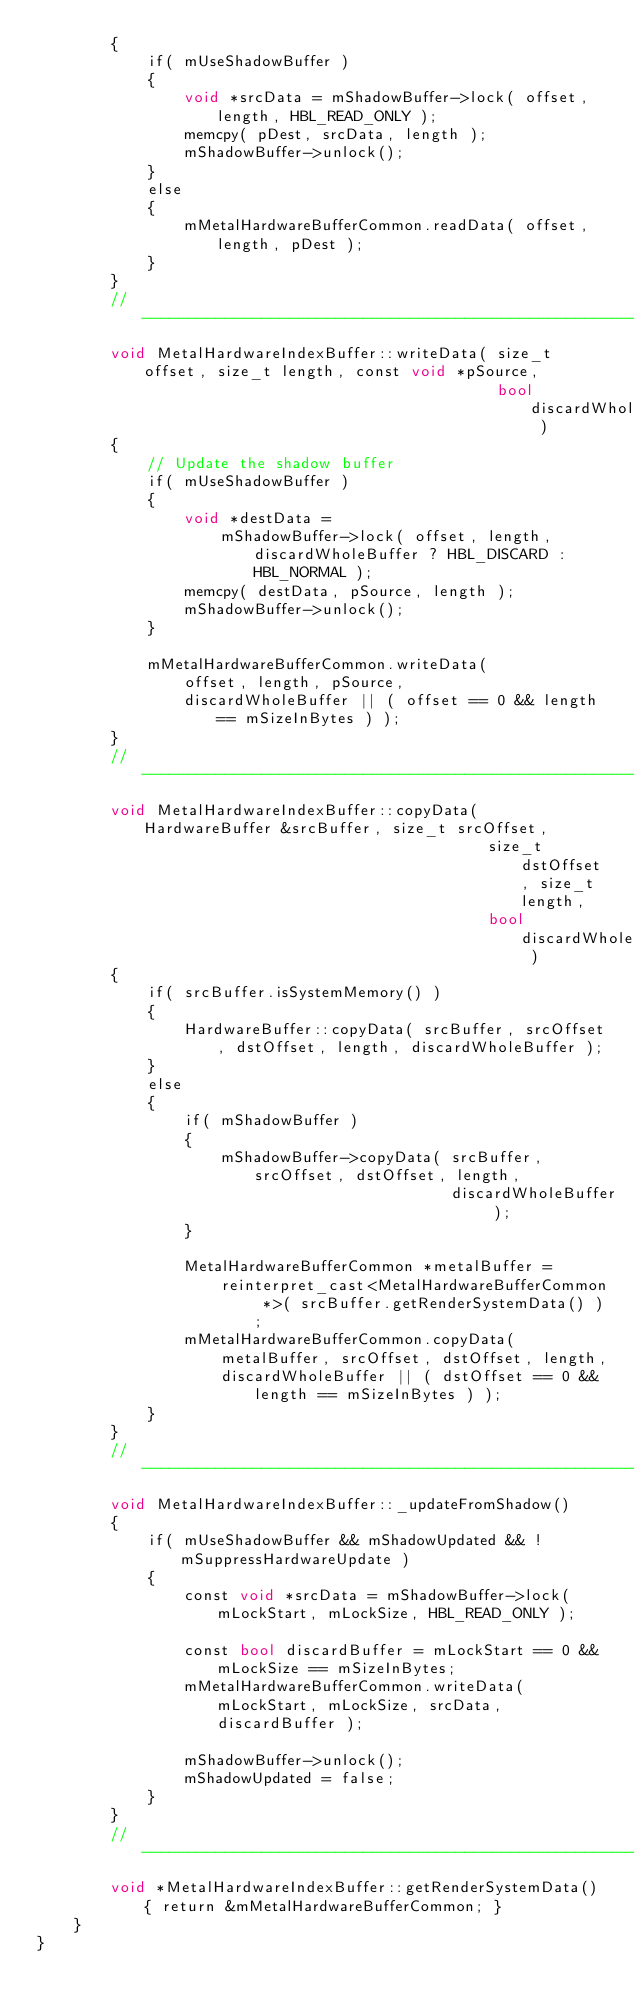Convert code to text. <code><loc_0><loc_0><loc_500><loc_500><_ObjectiveC_>        {
            if( mUseShadowBuffer )
            {
                void *srcData = mShadowBuffer->lock( offset, length, HBL_READ_ONLY );
                memcpy( pDest, srcData, length );
                mShadowBuffer->unlock();
            }
            else
            {
                mMetalHardwareBufferCommon.readData( offset, length, pDest );
            }
        }
        //-----------------------------------------------------------------------------------
        void MetalHardwareIndexBuffer::writeData( size_t offset, size_t length, const void *pSource,
                                                  bool discardWholeBuffer )
        {
            // Update the shadow buffer
            if( mUseShadowBuffer )
            {
                void *destData =
                    mShadowBuffer->lock( offset, length, discardWholeBuffer ? HBL_DISCARD : HBL_NORMAL );
                memcpy( destData, pSource, length );
                mShadowBuffer->unlock();
            }

            mMetalHardwareBufferCommon.writeData(
                offset, length, pSource,
                discardWholeBuffer || ( offset == 0 && length == mSizeInBytes ) );
        }
        //-----------------------------------------------------------------------------------
        void MetalHardwareIndexBuffer::copyData( HardwareBuffer &srcBuffer, size_t srcOffset,
                                                 size_t dstOffset, size_t length,
                                                 bool discardWholeBuffer )
        {
            if( srcBuffer.isSystemMemory() )
            {
                HardwareBuffer::copyData( srcBuffer, srcOffset, dstOffset, length, discardWholeBuffer );
            }
            else
            {
                if( mShadowBuffer )
                {
                    mShadowBuffer->copyData( srcBuffer, srcOffset, dstOffset, length,
                                             discardWholeBuffer );
                }

                MetalHardwareBufferCommon *metalBuffer =
                    reinterpret_cast<MetalHardwareBufferCommon *>( srcBuffer.getRenderSystemData() );
                mMetalHardwareBufferCommon.copyData(
                    metalBuffer, srcOffset, dstOffset, length,
                    discardWholeBuffer || ( dstOffset == 0 && length == mSizeInBytes ) );
            }
        }
        //-----------------------------------------------------------------------------------
        void MetalHardwareIndexBuffer::_updateFromShadow()
        {
            if( mUseShadowBuffer && mShadowUpdated && !mSuppressHardwareUpdate )
            {
                const void *srcData = mShadowBuffer->lock( mLockStart, mLockSize, HBL_READ_ONLY );

                const bool discardBuffer = mLockStart == 0 && mLockSize == mSizeInBytes;
                mMetalHardwareBufferCommon.writeData( mLockStart, mLockSize, srcData, discardBuffer );

                mShadowBuffer->unlock();
                mShadowUpdated = false;
            }
        }
        //-----------------------------------------------------------------------------------
        void *MetalHardwareIndexBuffer::getRenderSystemData() { return &mMetalHardwareBufferCommon; }
    }
}
</code> 